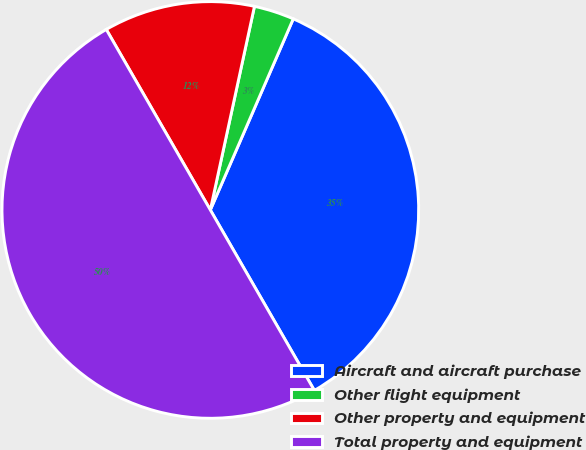Convert chart. <chart><loc_0><loc_0><loc_500><loc_500><pie_chart><fcel>Aircraft and aircraft purchase<fcel>Other flight equipment<fcel>Other property and equipment<fcel>Total property and equipment<nl><fcel>35.16%<fcel>3.12%<fcel>11.72%<fcel>50.0%<nl></chart> 